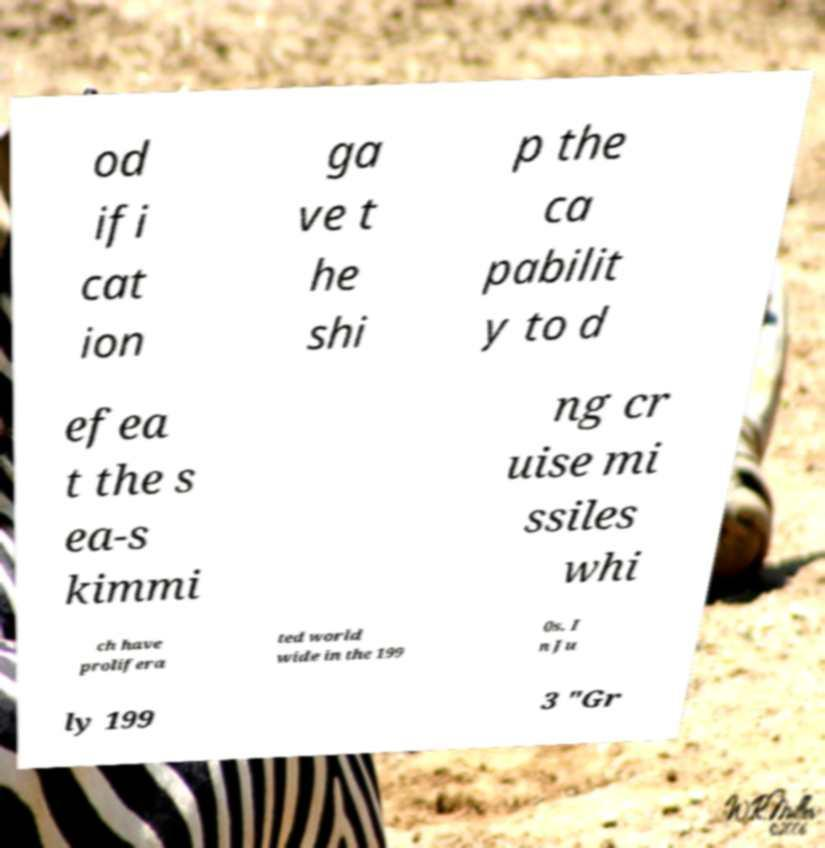What messages or text are displayed in this image? I need them in a readable, typed format. od ifi cat ion ga ve t he shi p the ca pabilit y to d efea t the s ea-s kimmi ng cr uise mi ssiles whi ch have prolifera ted world wide in the 199 0s. I n Ju ly 199 3 "Gr 